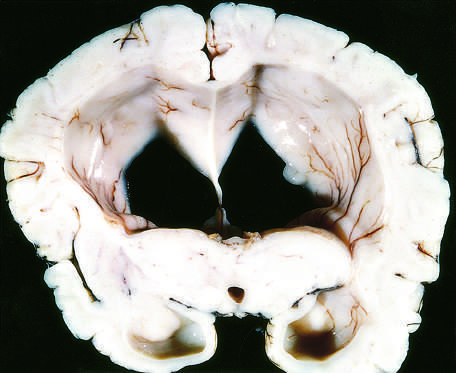re such changes associated with a dangerous increase in intra-cranial pressure?
Answer the question using a single word or phrase. Yes 